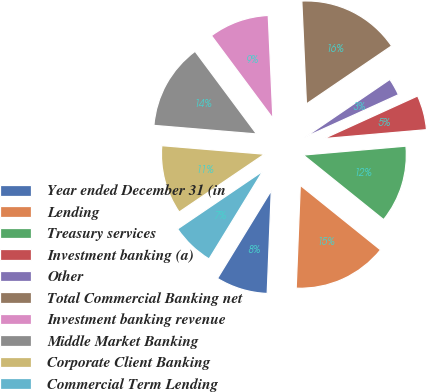Convert chart. <chart><loc_0><loc_0><loc_500><loc_500><pie_chart><fcel>Year ended December 31 (in<fcel>Lending<fcel>Treasury services<fcel>Investment banking (a)<fcel>Other<fcel>Total Commercial Banking net<fcel>Investment banking revenue<fcel>Middle Market Banking<fcel>Corporate Client Banking<fcel>Commercial Term Lending<nl><fcel>8.11%<fcel>14.85%<fcel>12.16%<fcel>5.42%<fcel>2.72%<fcel>16.2%<fcel>9.46%<fcel>13.5%<fcel>10.81%<fcel>6.77%<nl></chart> 